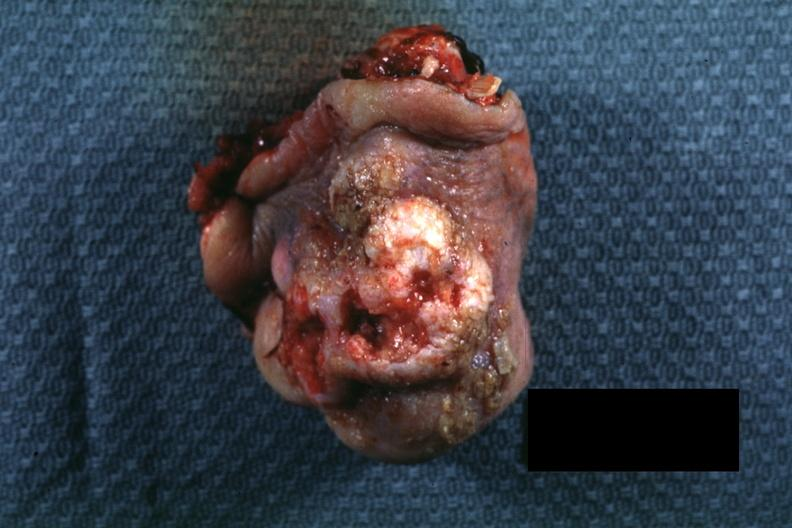how does this image show portion of nose typical exophytic lesion?
Answer the question using a single word or phrase. With heaped-up margins and central ulceration 